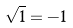<formula> <loc_0><loc_0><loc_500><loc_500>\sqrt { 1 } = - 1</formula> 